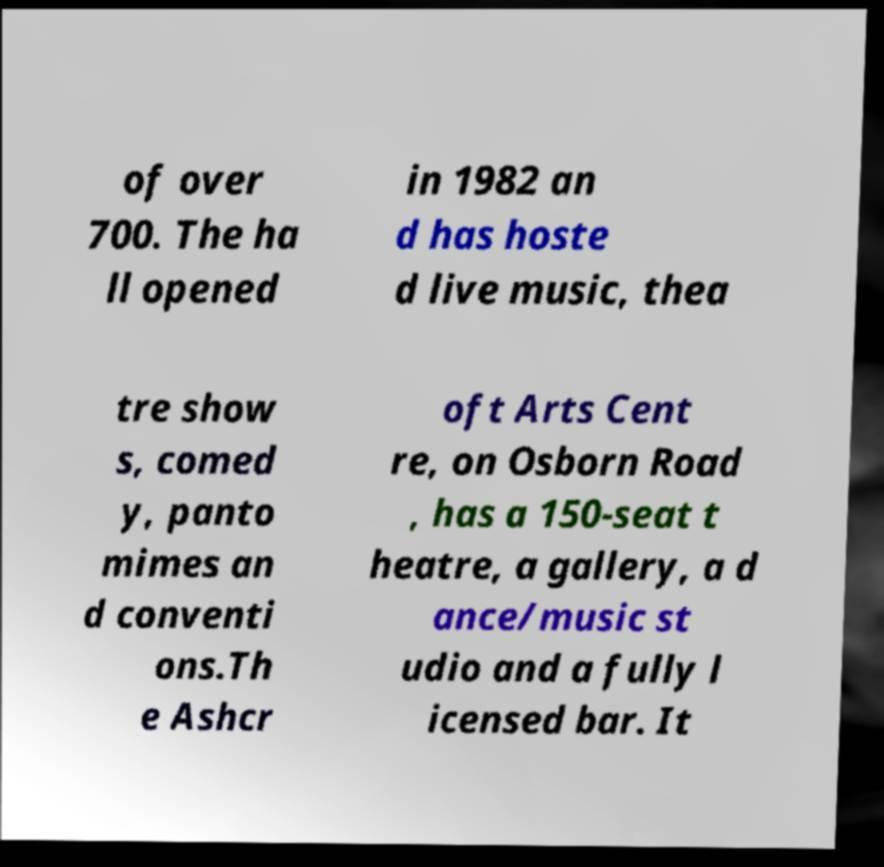For documentation purposes, I need the text within this image transcribed. Could you provide that? of over 700. The ha ll opened in 1982 an d has hoste d live music, thea tre show s, comed y, panto mimes an d conventi ons.Th e Ashcr oft Arts Cent re, on Osborn Road , has a 150-seat t heatre, a gallery, a d ance/music st udio and a fully l icensed bar. It 